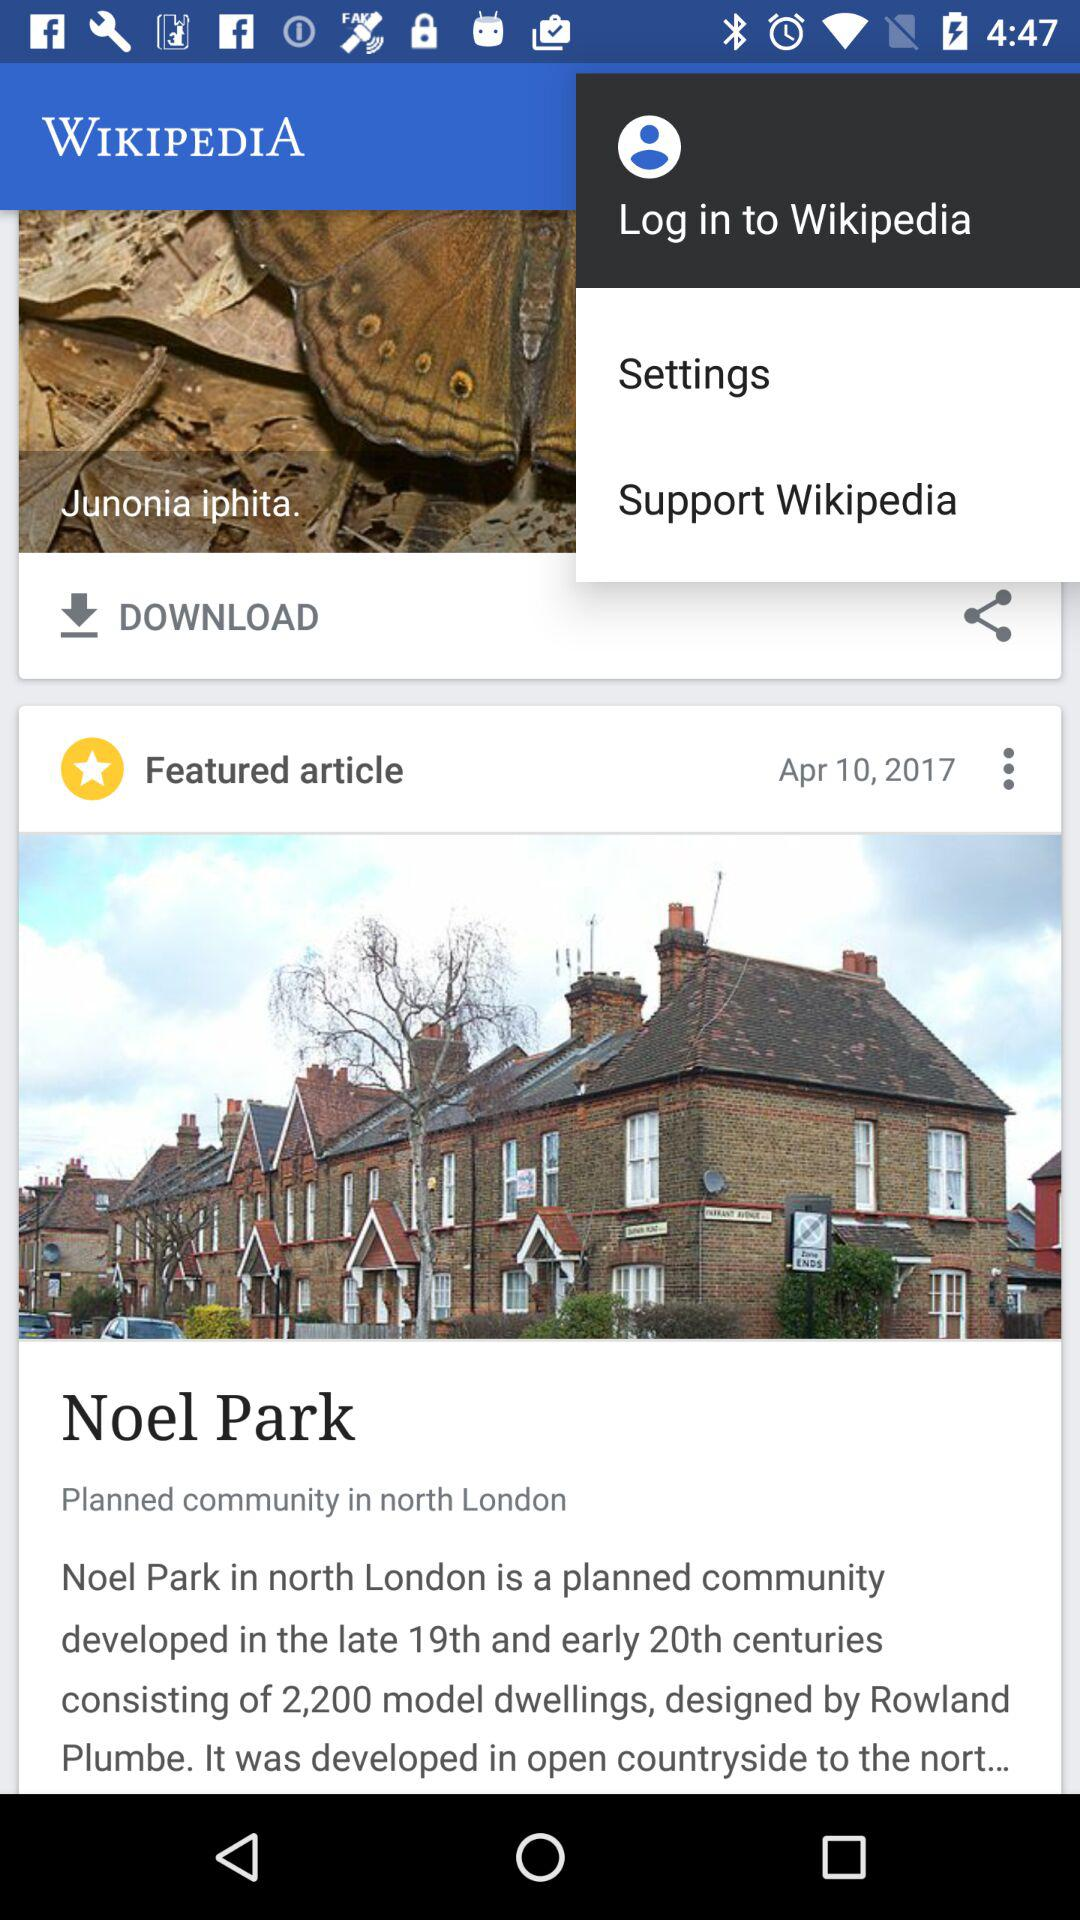What is the publication date of the article? The publication date of the article is April 10, 2017. 